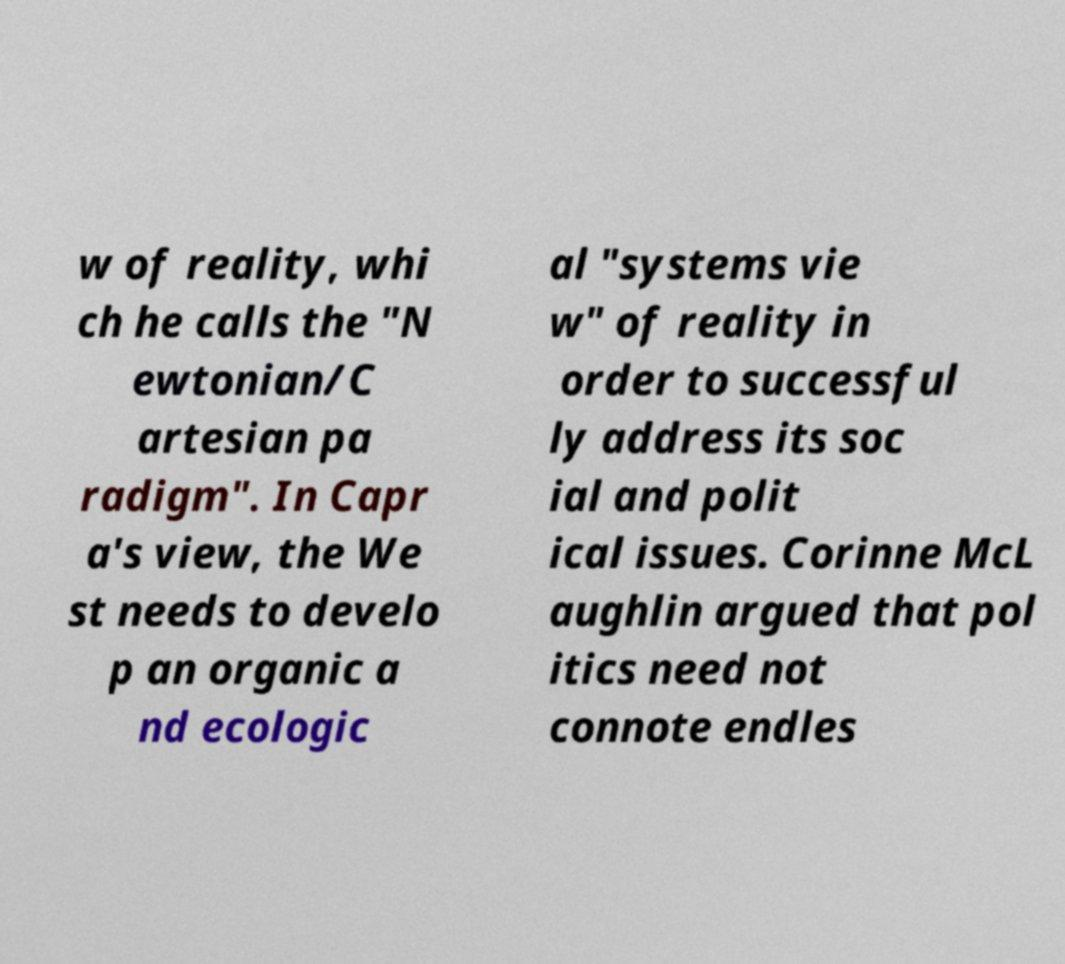There's text embedded in this image that I need extracted. Can you transcribe it verbatim? w of reality, whi ch he calls the "N ewtonian/C artesian pa radigm". In Capr a's view, the We st needs to develo p an organic a nd ecologic al "systems vie w" of reality in order to successful ly address its soc ial and polit ical issues. Corinne McL aughlin argued that pol itics need not connote endles 